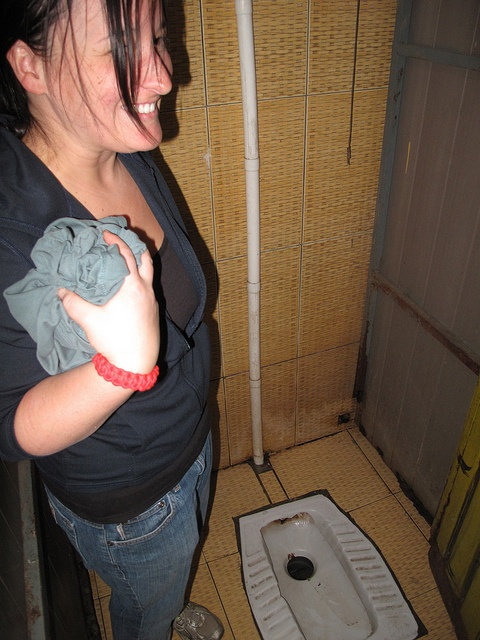Describe the objects in this image and their specific colors. I can see people in black, salmon, and darkgray tones and toilet in black and gray tones in this image. 